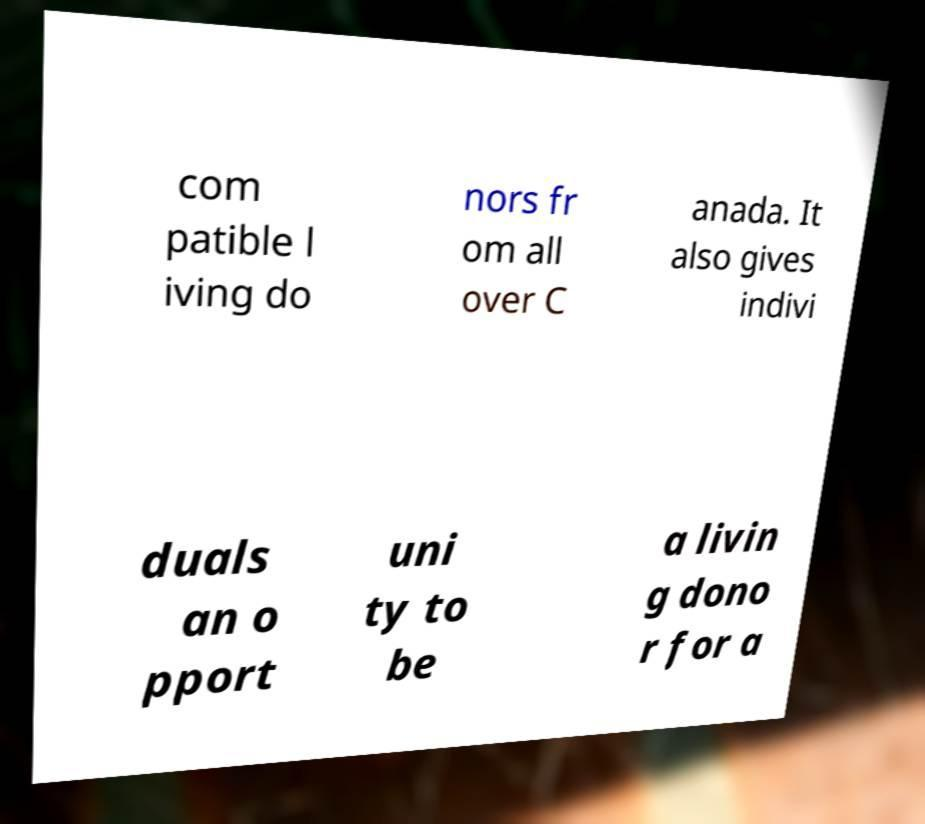Please read and relay the text visible in this image. What does it say? com patible l iving do nors fr om all over C anada. It also gives indivi duals an o pport uni ty to be a livin g dono r for a 